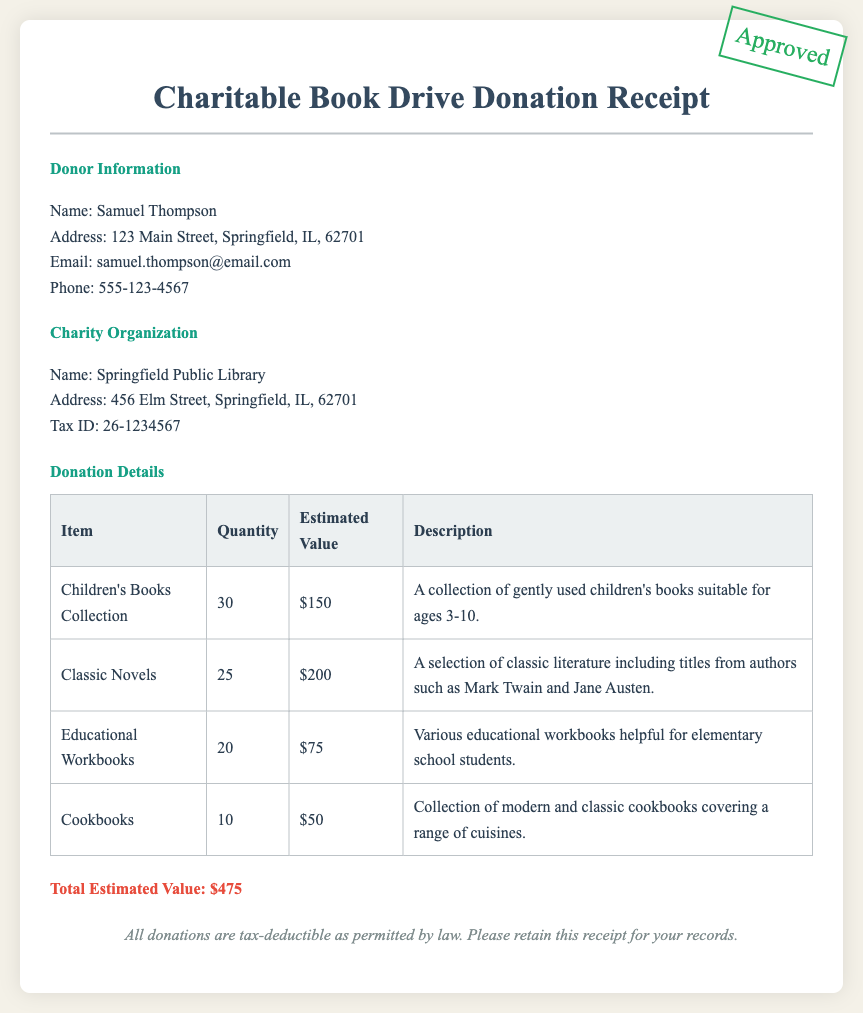What is the donor's name? The donor's name is specified in the "Donor Information" section of the document.
Answer: Samuel Thompson What is the total estimated value of the donation? The total estimated value is calculated from the sum of all items listed in the "Donation Details" section.
Answer: $475 How many children's books were donated? The quantity of children's books donated is detailed in the "Donation Details" table.
Answer: 30 What charity organization received the donation? The name of the charity organization is outlined in the "Charity Organization" section.
Answer: Springfield Public Library What is the tax ID of the charity organization? The tax ID can be found in the "Charity Organization" section of the document.
Answer: 26-1234567 Are donations tax-deductible? The footer of the document specifies the tax status of the donations.
Answer: Yes Which item had the highest estimated value? The estimate for each item can be found in the "Donation Details" table, allowing for comparison.
Answer: Classic Novels How many educational workbooks were donated? The count for educational workbooks is specified in the "Donation Details" section.
Answer: 20 What is the description of the cookbooks donated? The "Donation Details" table includes descriptions for each item donated, including cookbooks.
Answer: Collection of modern and classic cookbooks covering a range of cuisines 